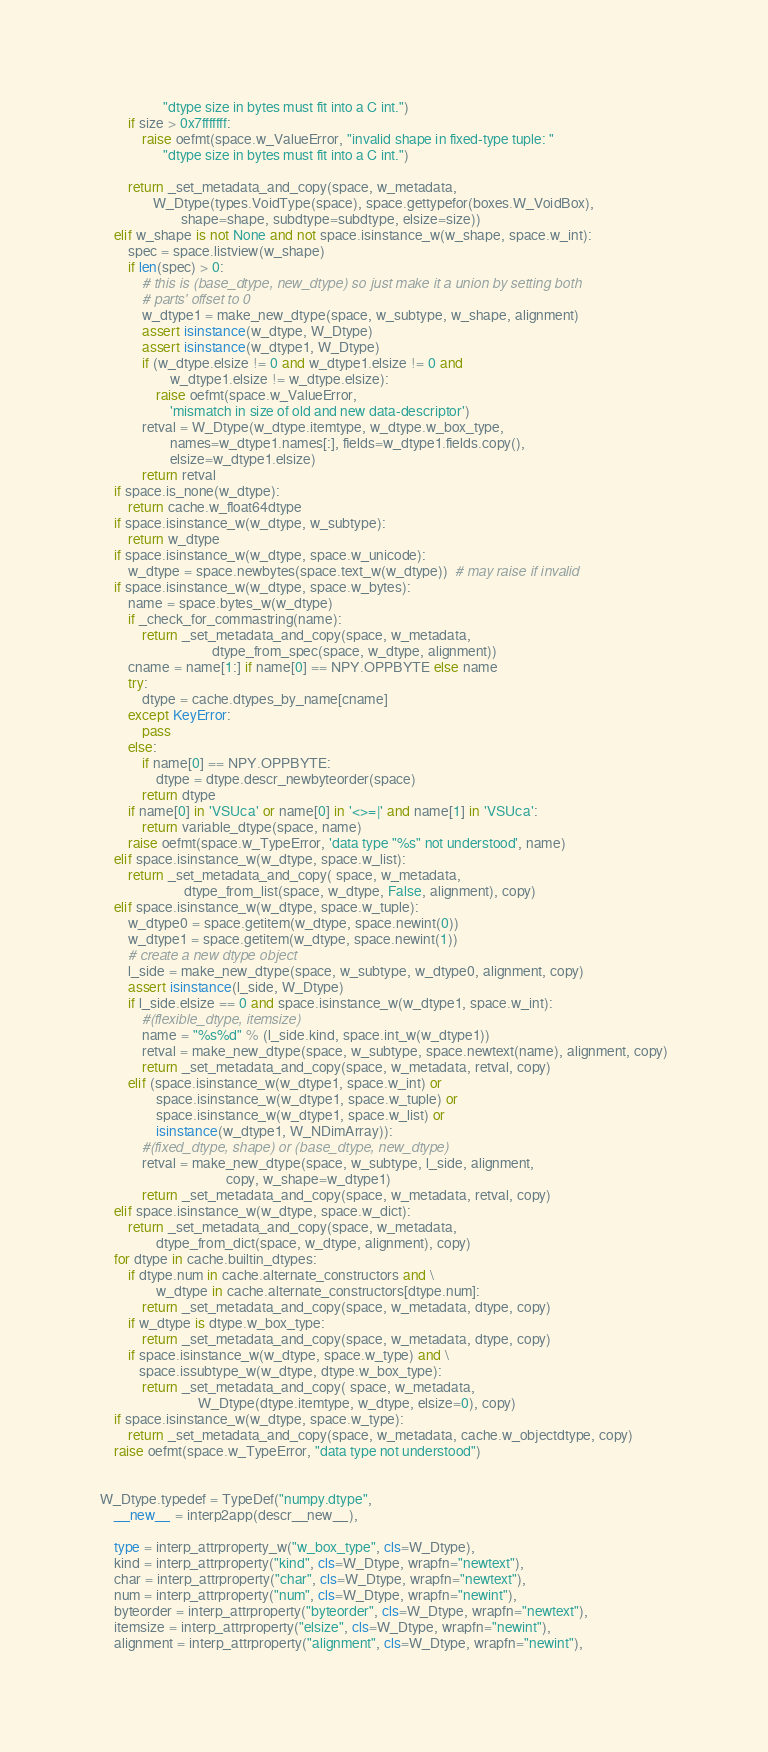<code> <loc_0><loc_0><loc_500><loc_500><_Python_>                  "dtype size in bytes must fit into a C int.")
        if size > 0x7fffffff:
            raise oefmt(space.w_ValueError, "invalid shape in fixed-type tuple: "
                  "dtype size in bytes must fit into a C int.")
        
        return _set_metadata_and_copy(space, w_metadata,
               W_Dtype(types.VoidType(space), space.gettypefor(boxes.W_VoidBox),
                       shape=shape, subdtype=subdtype, elsize=size))
    elif w_shape is not None and not space.isinstance_w(w_shape, space.w_int):
        spec = space.listview(w_shape)
        if len(spec) > 0:
            # this is (base_dtype, new_dtype) so just make it a union by setting both
            # parts' offset to 0
            w_dtype1 = make_new_dtype(space, w_subtype, w_shape, alignment)
            assert isinstance(w_dtype, W_Dtype)
            assert isinstance(w_dtype1, W_Dtype)
            if (w_dtype.elsize != 0 and w_dtype1.elsize != 0 and 
                    w_dtype1.elsize != w_dtype.elsize):
                raise oefmt(space.w_ValueError,
                    'mismatch in size of old and new data-descriptor')
            retval = W_Dtype(w_dtype.itemtype, w_dtype.w_box_type,
                    names=w_dtype1.names[:], fields=w_dtype1.fields.copy(),
                    elsize=w_dtype1.elsize)
            return retval
    if space.is_none(w_dtype):
        return cache.w_float64dtype
    if space.isinstance_w(w_dtype, w_subtype):
        return w_dtype
    if space.isinstance_w(w_dtype, space.w_unicode):
        w_dtype = space.newbytes(space.text_w(w_dtype))  # may raise if invalid
    if space.isinstance_w(w_dtype, space.w_bytes):
        name = space.bytes_w(w_dtype)
        if _check_for_commastring(name):
            return _set_metadata_and_copy(space, w_metadata,
                                dtype_from_spec(space, w_dtype, alignment))
        cname = name[1:] if name[0] == NPY.OPPBYTE else name
        try:
            dtype = cache.dtypes_by_name[cname]
        except KeyError:
            pass
        else:
            if name[0] == NPY.OPPBYTE:
                dtype = dtype.descr_newbyteorder(space)
            return dtype
        if name[0] in 'VSUca' or name[0] in '<>=|' and name[1] in 'VSUca':
            return variable_dtype(space, name)
        raise oefmt(space.w_TypeError, 'data type "%s" not understood', name)
    elif space.isinstance_w(w_dtype, space.w_list):
        return _set_metadata_and_copy( space, w_metadata,
                        dtype_from_list(space, w_dtype, False, alignment), copy)
    elif space.isinstance_w(w_dtype, space.w_tuple):
        w_dtype0 = space.getitem(w_dtype, space.newint(0))
        w_dtype1 = space.getitem(w_dtype, space.newint(1))
        # create a new dtype object
        l_side = make_new_dtype(space, w_subtype, w_dtype0, alignment, copy)
        assert isinstance(l_side, W_Dtype)
        if l_side.elsize == 0 and space.isinstance_w(w_dtype1, space.w_int):
            #(flexible_dtype, itemsize)
            name = "%s%d" % (l_side.kind, space.int_w(w_dtype1))
            retval = make_new_dtype(space, w_subtype, space.newtext(name), alignment, copy)
            return _set_metadata_and_copy(space, w_metadata, retval, copy)
        elif (space.isinstance_w(w_dtype1, space.w_int) or
                space.isinstance_w(w_dtype1, space.w_tuple) or 
                space.isinstance_w(w_dtype1, space.w_list) or 
                isinstance(w_dtype1, W_NDimArray)):
            #(fixed_dtype, shape) or (base_dtype, new_dtype)
            retval = make_new_dtype(space, w_subtype, l_side, alignment,
                                    copy, w_shape=w_dtype1)
            return _set_metadata_and_copy(space, w_metadata, retval, copy)
    elif space.isinstance_w(w_dtype, space.w_dict):
        return _set_metadata_and_copy(space, w_metadata,
                dtype_from_dict(space, w_dtype, alignment), copy)
    for dtype in cache.builtin_dtypes:
        if dtype.num in cache.alternate_constructors and \
                w_dtype in cache.alternate_constructors[dtype.num]:
            return _set_metadata_and_copy(space, w_metadata, dtype, copy)
        if w_dtype is dtype.w_box_type:
            return _set_metadata_and_copy(space, w_metadata, dtype, copy)
        if space.isinstance_w(w_dtype, space.w_type) and \
           space.issubtype_w(w_dtype, dtype.w_box_type):
            return _set_metadata_and_copy( space, w_metadata,
                            W_Dtype(dtype.itemtype, w_dtype, elsize=0), copy)
    if space.isinstance_w(w_dtype, space.w_type):
        return _set_metadata_and_copy(space, w_metadata, cache.w_objectdtype, copy)
    raise oefmt(space.w_TypeError, "data type not understood")


W_Dtype.typedef = TypeDef("numpy.dtype",
    __new__ = interp2app(descr__new__),

    type = interp_attrproperty_w("w_box_type", cls=W_Dtype),
    kind = interp_attrproperty("kind", cls=W_Dtype, wrapfn="newtext"),
    char = interp_attrproperty("char", cls=W_Dtype, wrapfn="newtext"),
    num = interp_attrproperty("num", cls=W_Dtype, wrapfn="newint"),
    byteorder = interp_attrproperty("byteorder", cls=W_Dtype, wrapfn="newtext"),
    itemsize = interp_attrproperty("elsize", cls=W_Dtype, wrapfn="newint"),
    alignment = interp_attrproperty("alignment", cls=W_Dtype, wrapfn="newint"),
</code> 